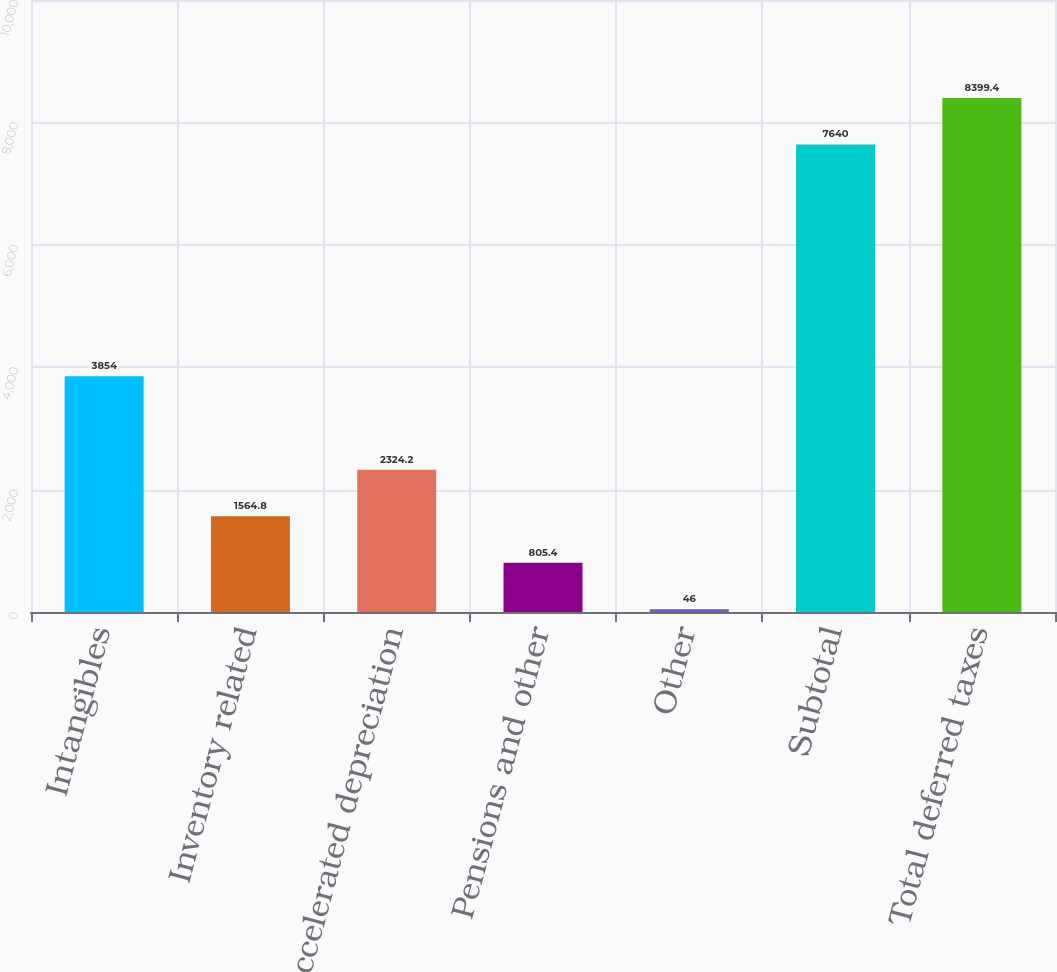Convert chart. <chart><loc_0><loc_0><loc_500><loc_500><bar_chart><fcel>Intangibles<fcel>Inventory related<fcel>Accelerated depreciation<fcel>Pensions and other<fcel>Other<fcel>Subtotal<fcel>Total deferred taxes<nl><fcel>3854<fcel>1564.8<fcel>2324.2<fcel>805.4<fcel>46<fcel>7640<fcel>8399.4<nl></chart> 